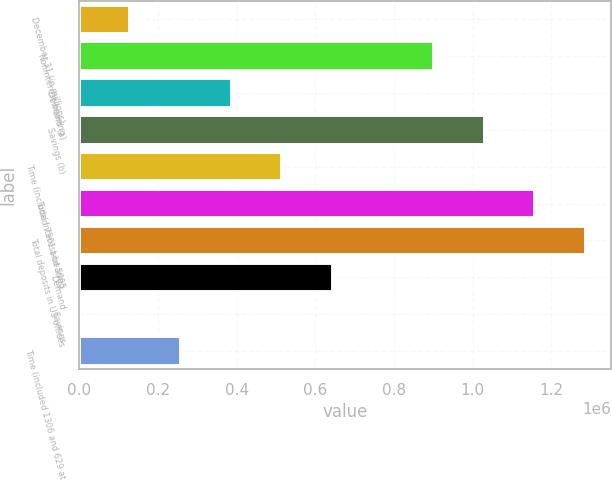Convert chart. <chart><loc_0><loc_0><loc_500><loc_500><bar_chart><fcel>December 31 (in millions)<fcel>Noninterest-bearing<fcel>Demand (a)<fcel>Savings (b)<fcel>Time (included 7501 and 5995<fcel>Total interest-bearing<fcel>Total deposits in US offices<fcel>Demand<fcel>Savings<fcel>Time (included 1306 and 629 at<nl><fcel>129751<fcel>901760<fcel>387088<fcel>1.03043e+06<fcel>515756<fcel>1.1591e+06<fcel>1.28776e+06<fcel>644424<fcel>1083<fcel>258419<nl></chart> 